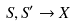Convert formula to latex. <formula><loc_0><loc_0><loc_500><loc_500>S , S ^ { \prime } \rightarrow X</formula> 